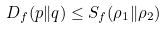Convert formula to latex. <formula><loc_0><loc_0><loc_500><loc_500>D _ { f } ( p \| q ) \leq S _ { f } ( \rho _ { 1 } \| \rho _ { 2 } )</formula> 